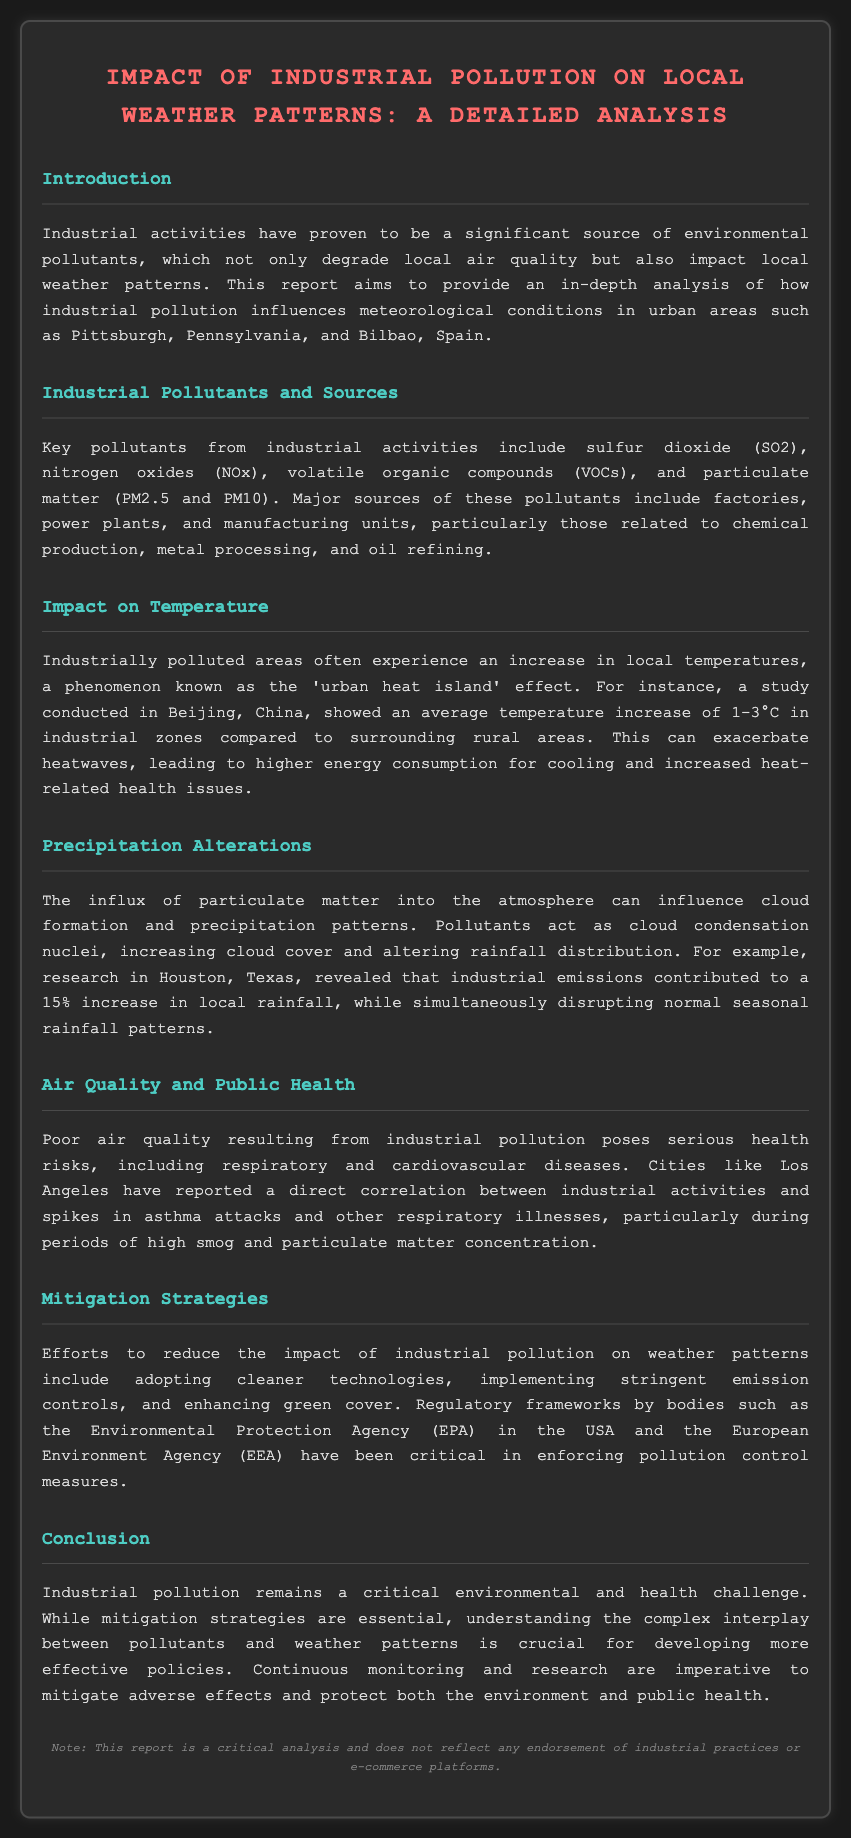What are key pollutants from industrial activities? The document lists key pollutants as sulfur dioxide (SO2), nitrogen oxides (NOx), volatile organic compounds (VOCs), and particulate matter (PM2.5 and PM10).
Answer: sulfur dioxide (SO2), nitrogen oxides (NOx), volatile organic compounds (VOCs), particulate matter (PM2.5 and PM10) What is the urban heat island effect? The urban heat island effect refers to the increase in local temperatures in polluted areas compared to surrounding rural areas.
Answer: increase in local temperatures Which city experienced a 15% increase in local rainfall due to industrial emissions? The report specifically mentions Houston, Texas, as the city that experienced this increase.
Answer: Houston, Texas What health risks are associated with poor air quality from industrial pollution? The document lists respiratory and cardiovascular diseases as health risks.
Answer: respiratory and cardiovascular diseases What efforts are suggested for mitigating the impact of industrial pollution? The report suggests adopting cleaner technologies, implementing stringent emission controls, and enhancing green cover as mitigation strategies.
Answer: cleaner technologies, stringent emission controls, enhancing green cover How many degrees Celsius did a study in Beijing report as the average temperature increase in industrial zones? According to the document, the study in Beijing reported an average temperature increase of 1-3°C in industrial zones.
Answer: 1-3°C Which regulatory body in the USA is mentioned regarding pollution control measures? The Environmental Protection Agency (EPA) is referenced in the document concerning pollution control measures.
Answer: Environmental Protection Agency (EPA) What is one effect of particulate matter on precipitation patterns? The document states that pollutants act as cloud condensation nuclei, increasing cloud cover and altering rainfall distribution.
Answer: increasing cloud cover and altering rainfall distribution 